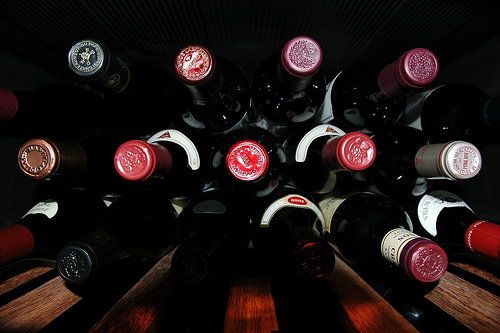<image>
Is there a plank next to the wine? No. The plank is not positioned next to the wine. They are located in different areas of the scene. 